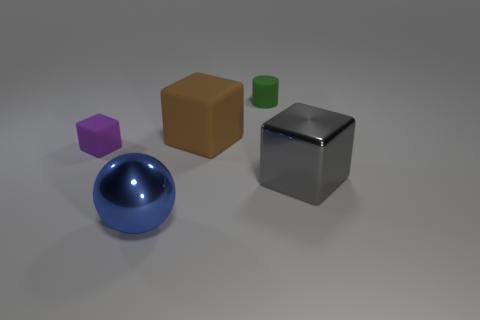How many objects are either big gray matte cubes or gray shiny things?
Keep it short and to the point. 1. What is the shape of the large object that is behind the big object that is to the right of the matte thing to the right of the big rubber thing?
Offer a terse response. Cube. Do the big thing behind the large gray object and the large blue object in front of the purple thing have the same material?
Offer a very short reply. No. What is the material of the big gray thing that is the same shape as the brown matte thing?
Your answer should be compact. Metal. Are there any other things that are the same size as the purple matte thing?
Provide a succinct answer. Yes. Does the tiny matte object that is behind the large brown block have the same shape as the rubber object that is left of the large blue sphere?
Give a very brief answer. No. Are there fewer blue shiny spheres that are on the left side of the large blue sphere than matte cylinders that are in front of the brown matte thing?
Ensure brevity in your answer.  No. How many other objects are the same shape as the gray object?
Offer a very short reply. 2. There is a large brown object that is the same material as the tiny cylinder; what shape is it?
Provide a short and direct response. Cube. The thing that is both on the left side of the green object and behind the small purple rubber cube is what color?
Keep it short and to the point. Brown. 